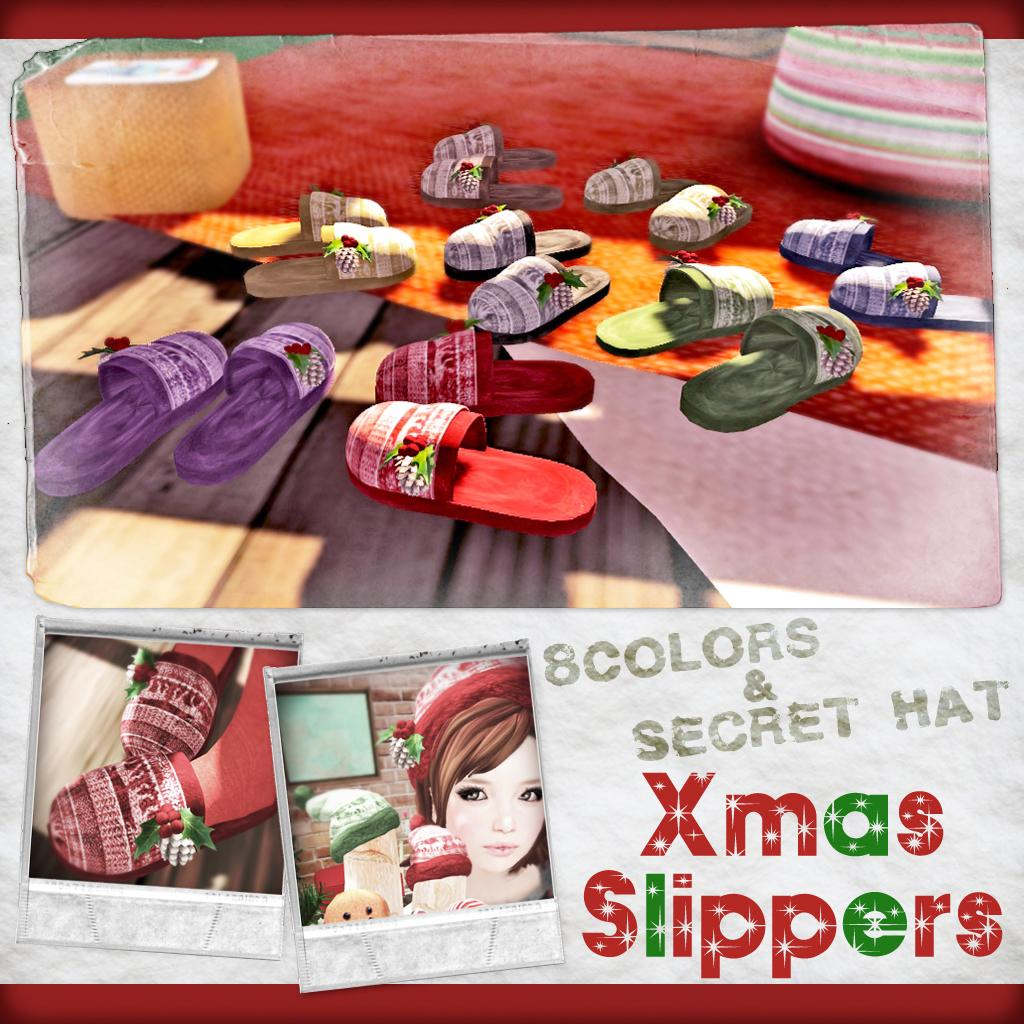What is the main subject of the pictures in the image? The main subject of the pictures in the image is footwear. Is there any other figure or object in the image besides the footwear? Yes, there is a depiction of a girl in the image. Where can we find text in the image? The text is written on the bottom right side of the image. What type of hook can be seen on the side of the girl in the image? There is no hook present on the side of the girl in the image. 